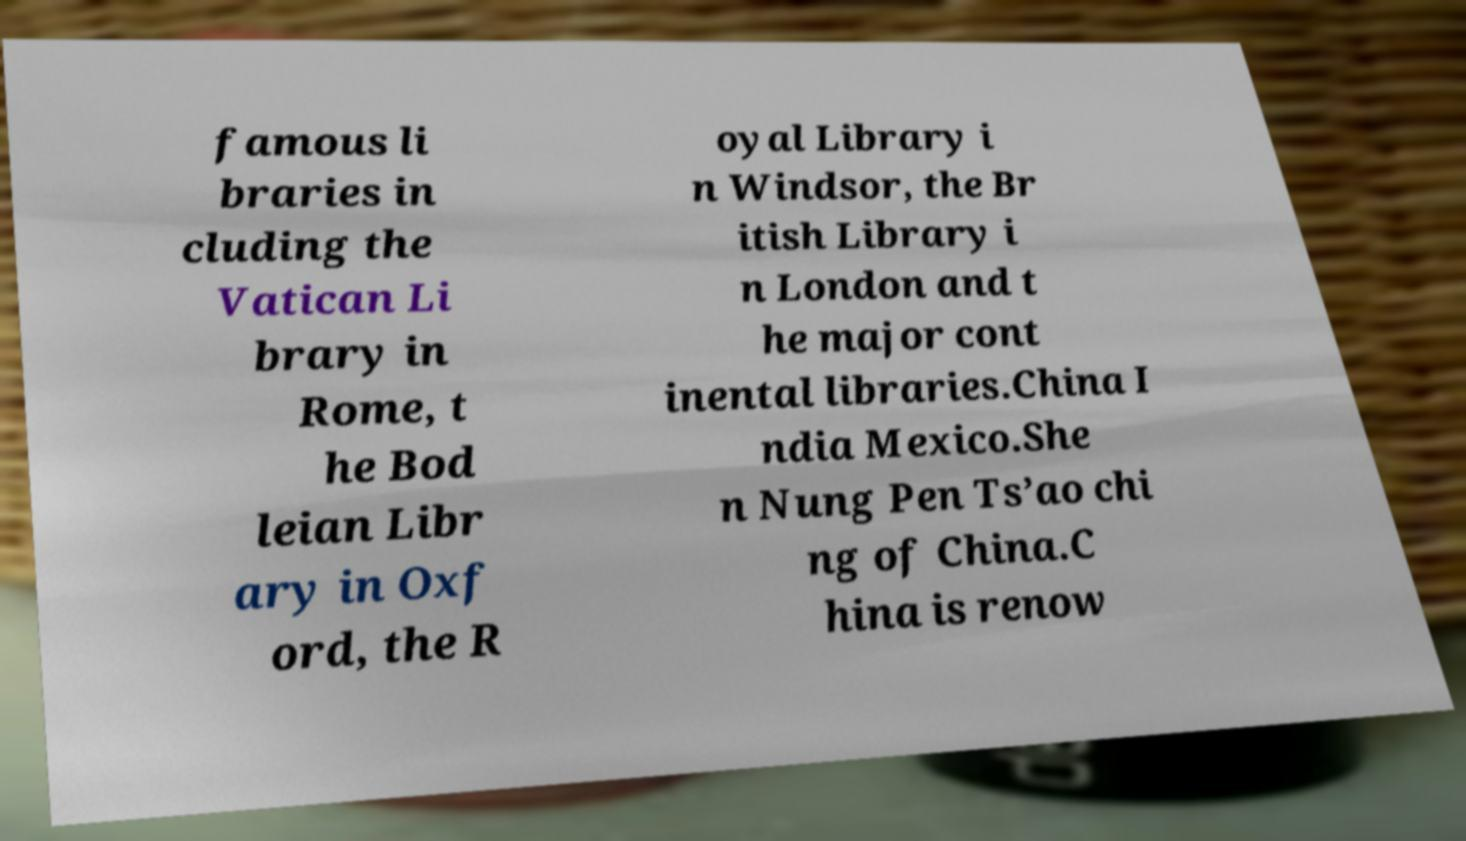Can you accurately transcribe the text from the provided image for me? famous li braries in cluding the Vatican Li brary in Rome, t he Bod leian Libr ary in Oxf ord, the R oyal Library i n Windsor, the Br itish Library i n London and t he major cont inental libraries.China I ndia Mexico.She n Nung Pen Ts’ao chi ng of China.C hina is renow 